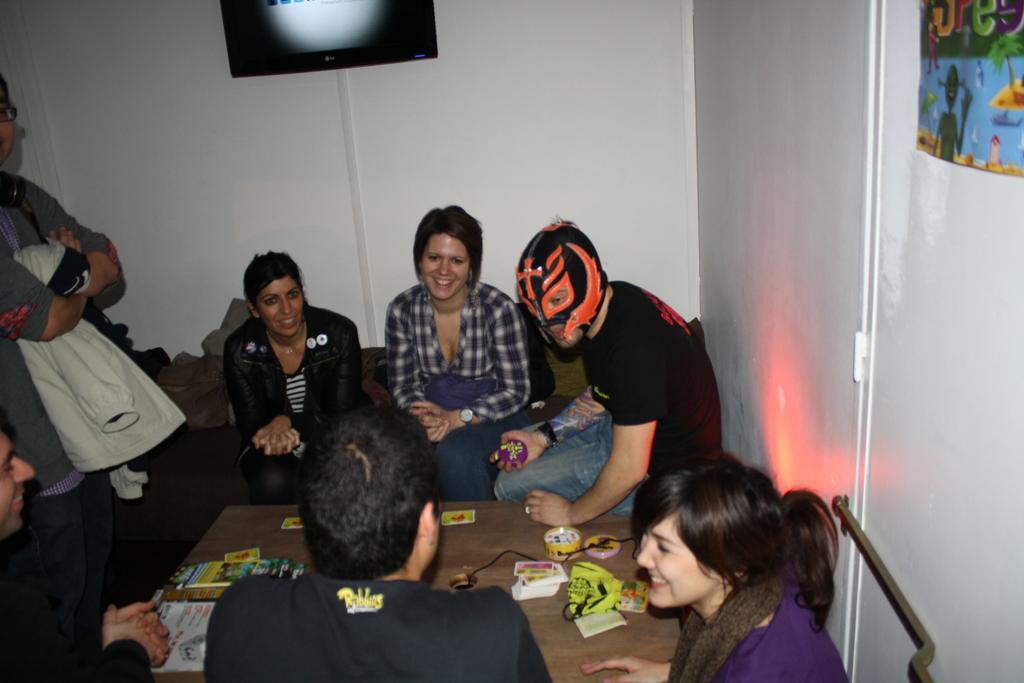Describe this image in one or two sentences. This picture is taken inside the room. In this image, we can see a group of people sitting in front of the table. On the table, we can see electric wires, playing cards. On the left side, we can see a person standing. In the background, we can see a monitor screen attached to a wall. On the left side, we can see a poster is attached to a wall. 